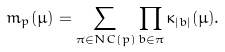Convert formula to latex. <formula><loc_0><loc_0><loc_500><loc_500>m _ { p } ( \mu ) = \sum _ { \pi \in N C ( p ) } \prod _ { b \in \pi } \kappa _ { | b | } ( \mu ) .</formula> 